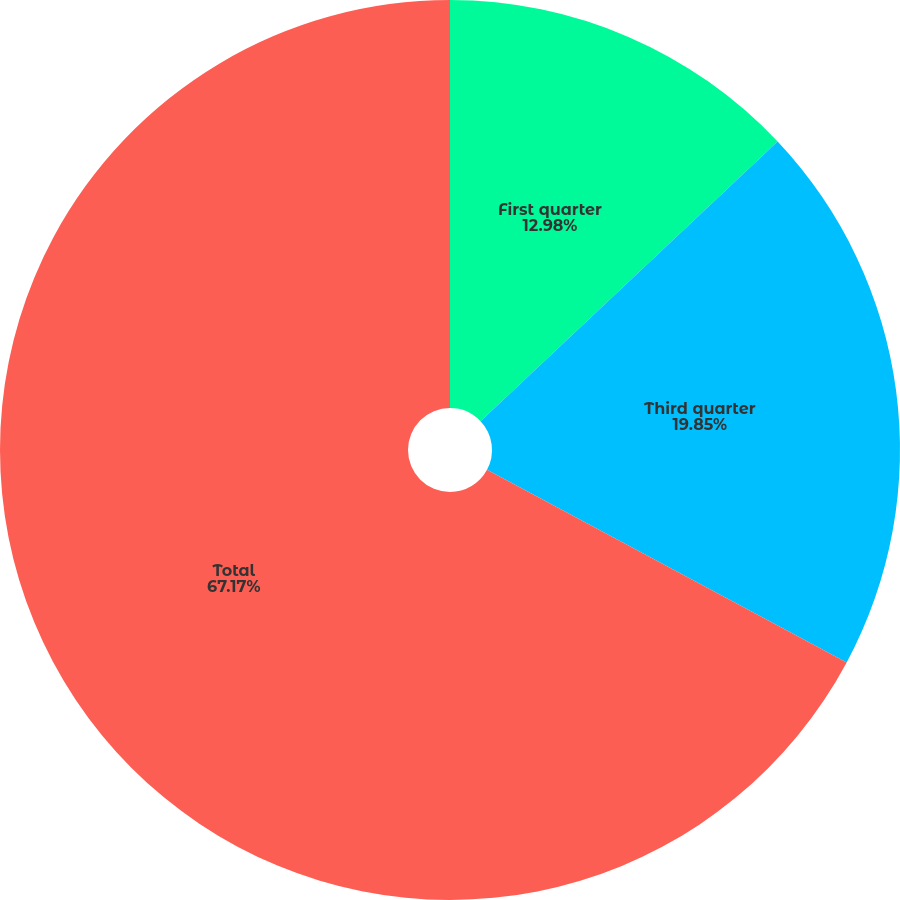<chart> <loc_0><loc_0><loc_500><loc_500><pie_chart><fcel>First quarter<fcel>Third quarter<fcel>Total<nl><fcel>12.98%<fcel>19.85%<fcel>67.18%<nl></chart> 